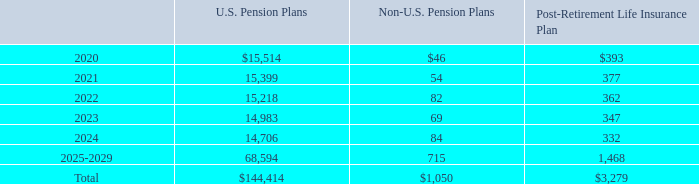NOTES TO CONSOLIDATED FINANCIAL STATEMENTS (in thousands, except for share and per share data)
We expect to make $493 of contributions to the U.S. plans and $261 of contributions to the non-U.S. plans during 2020.
The following benefit payments, which reflect expected future service, as appropriate, are expected to be paid:
How much does the company expect to pay for U.S. Pension Plans in 2021?
Answer scale should be: thousand. 15,399. How much does the company expect to pay for Post-Retirement Life Insurance Plans in 2023?
Answer scale should be: thousand. 347. How much does the company expect to contribute to the U.S. plans during 2020?
Answer scale should be: thousand. 493. How many years were expected payments to Non-U.S. Pension Plans less than $50 thousand for 2020-2024?  2020
Answer: 1. What was the difference in the total expected payments between Non-U.S. Pension Plans and Post-Retirement Life Insurance Plan?
Answer scale should be: thousand. 3,279-1,050
Answer: 2229. What was the percentage change in the expected payments to U.S. Pension Plans between 2023 and 2024?
Answer scale should be: percent.  (14,706 - 14,983 )/ 14,983 
Answer: -1.85. 